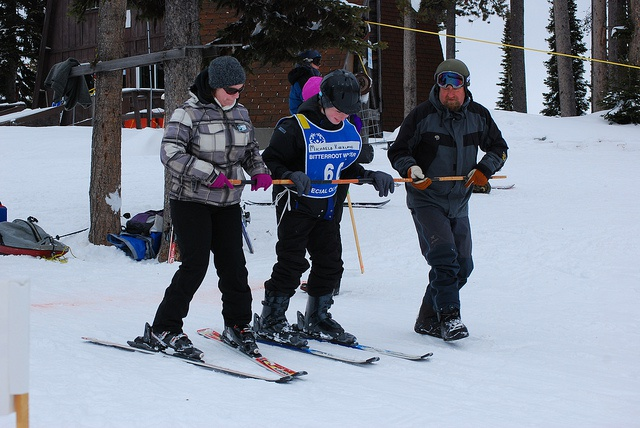Describe the objects in this image and their specific colors. I can see people in black, gray, and darkgray tones, people in black, darkblue, lightblue, and lightgray tones, people in black, gray, and maroon tones, skis in black, navy, gray, and darkgray tones, and skis in black, darkgray, and lightblue tones in this image. 